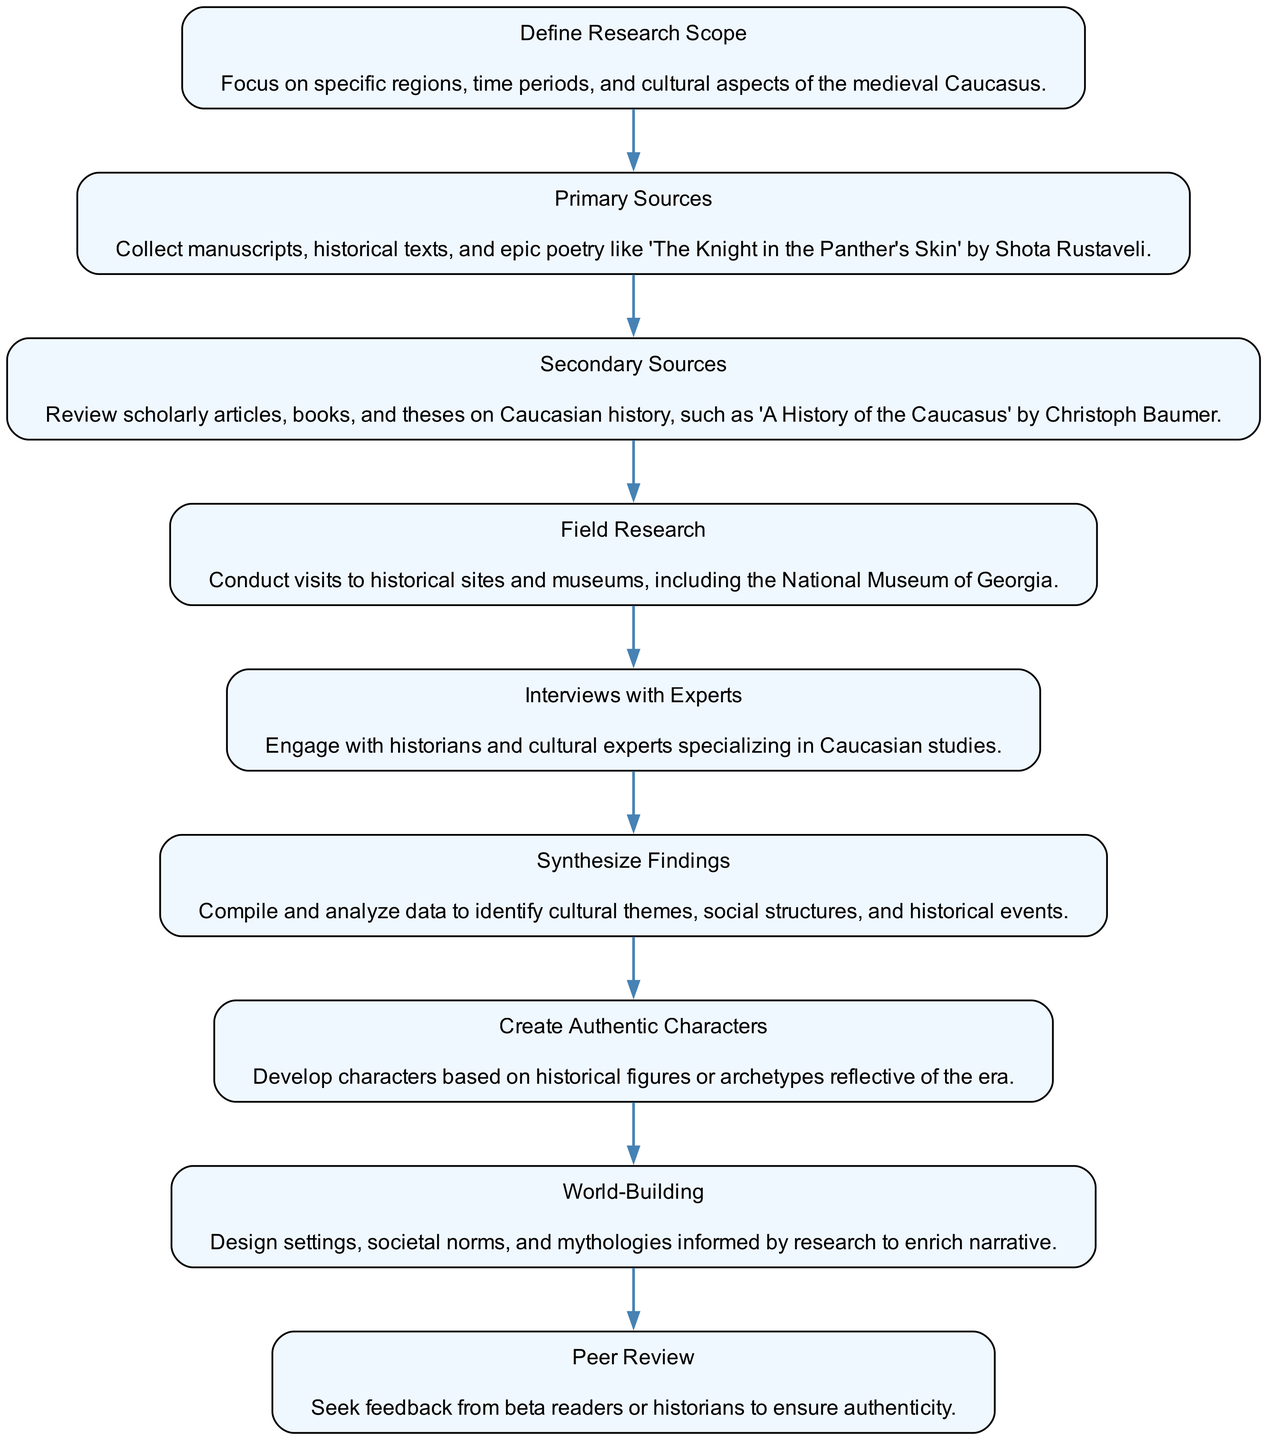What is the first step in the research workflow? The first step in the workflow is clearly defined in the diagram as "Define Research Scope."
Answer: Define Research Scope How many nodes are there in the diagram? By counting all the unique steps in the workflow, there are a total of 9 nodes represented in the diagram.
Answer: 9 Which step comes after "Primary Sources"? According to the flow of the diagram, the step that follows "Primary Sources" is "Secondary Sources."
Answer: Secondary Sources What is the last step in the research workflow? The last step indicated in the diagram is "Peer Review," which concludes the research workflow.
Answer: Peer Review In which step is fieldwork conducted? The diagram specifies that field research is conducted in the step titled "Field Research."
Answer: Field Research Which two steps involve the engagement with experts? The two steps that involve engagement with experts are "Interviews with Experts" and "Peer Review."
Answer: Interviews with Experts, Peer Review What do the steps "Synthesize Findings" and "World-Building" have in common? Both steps focus on utilizing research outcomes; "Synthesize Findings" analyzes data, while "World-Building" incorporates it into narrative elements.
Answer: Utilizing research outcomes How many edges are there connecting the nodes? The number of edges reflects the transitions between each step; there are 8 edges connecting the nodes in the flowchart.
Answer: 8 What type of sources does the step "Secondary Sources" refer to? "Secondary Sources" refers to scholarly articles, books, and theses on Caucasian history as highlighted in the diagram.
Answer: Scholarly articles, books, theses 